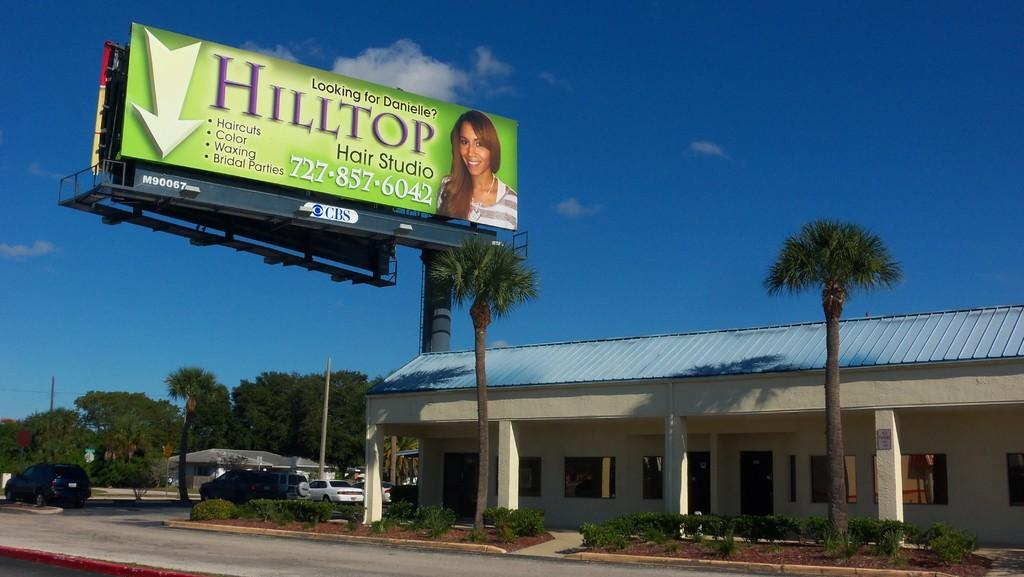<image>
Provide a brief description of the given image. The business name on the billboard ad is called "Hilltop Hair Studio." 